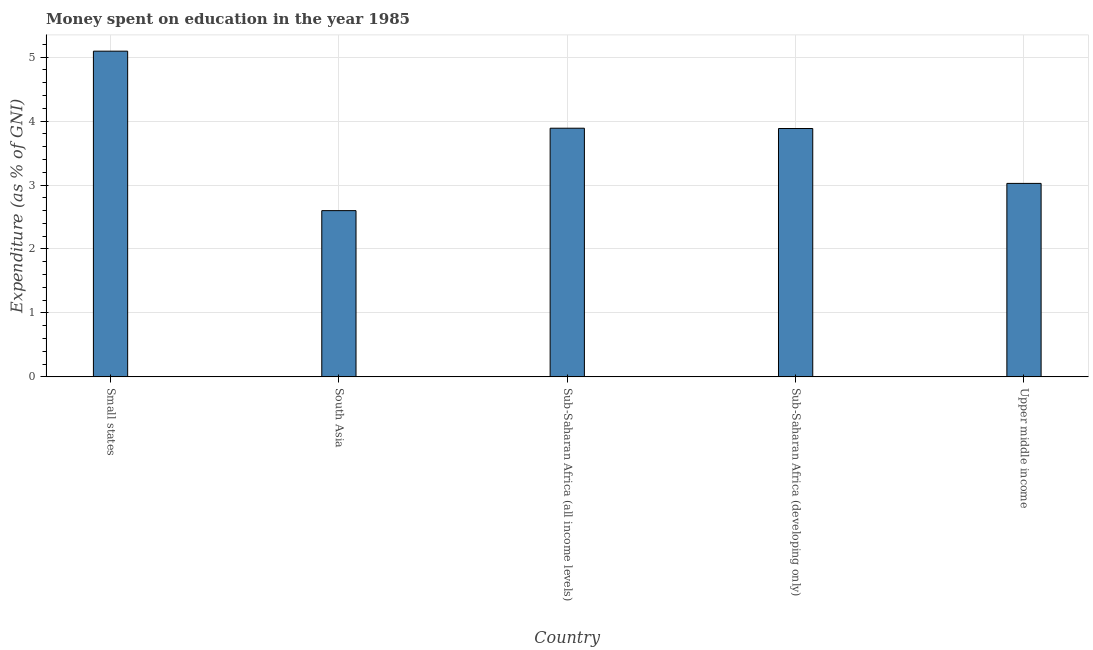What is the title of the graph?
Provide a short and direct response. Money spent on education in the year 1985. What is the label or title of the Y-axis?
Give a very brief answer. Expenditure (as % of GNI). What is the expenditure on education in South Asia?
Make the answer very short. 2.6. Across all countries, what is the maximum expenditure on education?
Keep it short and to the point. 5.09. Across all countries, what is the minimum expenditure on education?
Keep it short and to the point. 2.6. In which country was the expenditure on education maximum?
Give a very brief answer. Small states. In which country was the expenditure on education minimum?
Ensure brevity in your answer.  South Asia. What is the sum of the expenditure on education?
Ensure brevity in your answer.  18.49. What is the difference between the expenditure on education in South Asia and Upper middle income?
Your answer should be very brief. -0.43. What is the average expenditure on education per country?
Keep it short and to the point. 3.7. What is the median expenditure on education?
Your answer should be compact. 3.88. What is the ratio of the expenditure on education in Small states to that in South Asia?
Keep it short and to the point. 1.96. Is the difference between the expenditure on education in Sub-Saharan Africa (all income levels) and Sub-Saharan Africa (developing only) greater than the difference between any two countries?
Offer a terse response. No. What is the difference between the highest and the second highest expenditure on education?
Make the answer very short. 1.21. What is the difference between the highest and the lowest expenditure on education?
Offer a terse response. 2.49. In how many countries, is the expenditure on education greater than the average expenditure on education taken over all countries?
Your response must be concise. 3. How many bars are there?
Offer a terse response. 5. How many countries are there in the graph?
Ensure brevity in your answer.  5. What is the difference between two consecutive major ticks on the Y-axis?
Provide a short and direct response. 1. What is the Expenditure (as % of GNI) of Small states?
Give a very brief answer. 5.09. What is the Expenditure (as % of GNI) of South Asia?
Keep it short and to the point. 2.6. What is the Expenditure (as % of GNI) in Sub-Saharan Africa (all income levels)?
Offer a terse response. 3.89. What is the Expenditure (as % of GNI) in Sub-Saharan Africa (developing only)?
Keep it short and to the point. 3.88. What is the Expenditure (as % of GNI) in Upper middle income?
Offer a terse response. 3.03. What is the difference between the Expenditure (as % of GNI) in Small states and South Asia?
Your response must be concise. 2.49. What is the difference between the Expenditure (as % of GNI) in Small states and Sub-Saharan Africa (all income levels)?
Your answer should be very brief. 1.2. What is the difference between the Expenditure (as % of GNI) in Small states and Sub-Saharan Africa (developing only)?
Your answer should be very brief. 1.21. What is the difference between the Expenditure (as % of GNI) in Small states and Upper middle income?
Ensure brevity in your answer.  2.07. What is the difference between the Expenditure (as % of GNI) in South Asia and Sub-Saharan Africa (all income levels)?
Your answer should be compact. -1.29. What is the difference between the Expenditure (as % of GNI) in South Asia and Sub-Saharan Africa (developing only)?
Your answer should be compact. -1.28. What is the difference between the Expenditure (as % of GNI) in South Asia and Upper middle income?
Provide a short and direct response. -0.43. What is the difference between the Expenditure (as % of GNI) in Sub-Saharan Africa (all income levels) and Sub-Saharan Africa (developing only)?
Ensure brevity in your answer.  0. What is the difference between the Expenditure (as % of GNI) in Sub-Saharan Africa (all income levels) and Upper middle income?
Give a very brief answer. 0.86. What is the difference between the Expenditure (as % of GNI) in Sub-Saharan Africa (developing only) and Upper middle income?
Offer a terse response. 0.86. What is the ratio of the Expenditure (as % of GNI) in Small states to that in South Asia?
Keep it short and to the point. 1.96. What is the ratio of the Expenditure (as % of GNI) in Small states to that in Sub-Saharan Africa (all income levels)?
Your answer should be compact. 1.31. What is the ratio of the Expenditure (as % of GNI) in Small states to that in Sub-Saharan Africa (developing only)?
Give a very brief answer. 1.31. What is the ratio of the Expenditure (as % of GNI) in Small states to that in Upper middle income?
Your answer should be very brief. 1.68. What is the ratio of the Expenditure (as % of GNI) in South Asia to that in Sub-Saharan Africa (all income levels)?
Your answer should be compact. 0.67. What is the ratio of the Expenditure (as % of GNI) in South Asia to that in Sub-Saharan Africa (developing only)?
Make the answer very short. 0.67. What is the ratio of the Expenditure (as % of GNI) in South Asia to that in Upper middle income?
Give a very brief answer. 0.86. What is the ratio of the Expenditure (as % of GNI) in Sub-Saharan Africa (all income levels) to that in Upper middle income?
Ensure brevity in your answer.  1.28. What is the ratio of the Expenditure (as % of GNI) in Sub-Saharan Africa (developing only) to that in Upper middle income?
Your answer should be very brief. 1.28. 